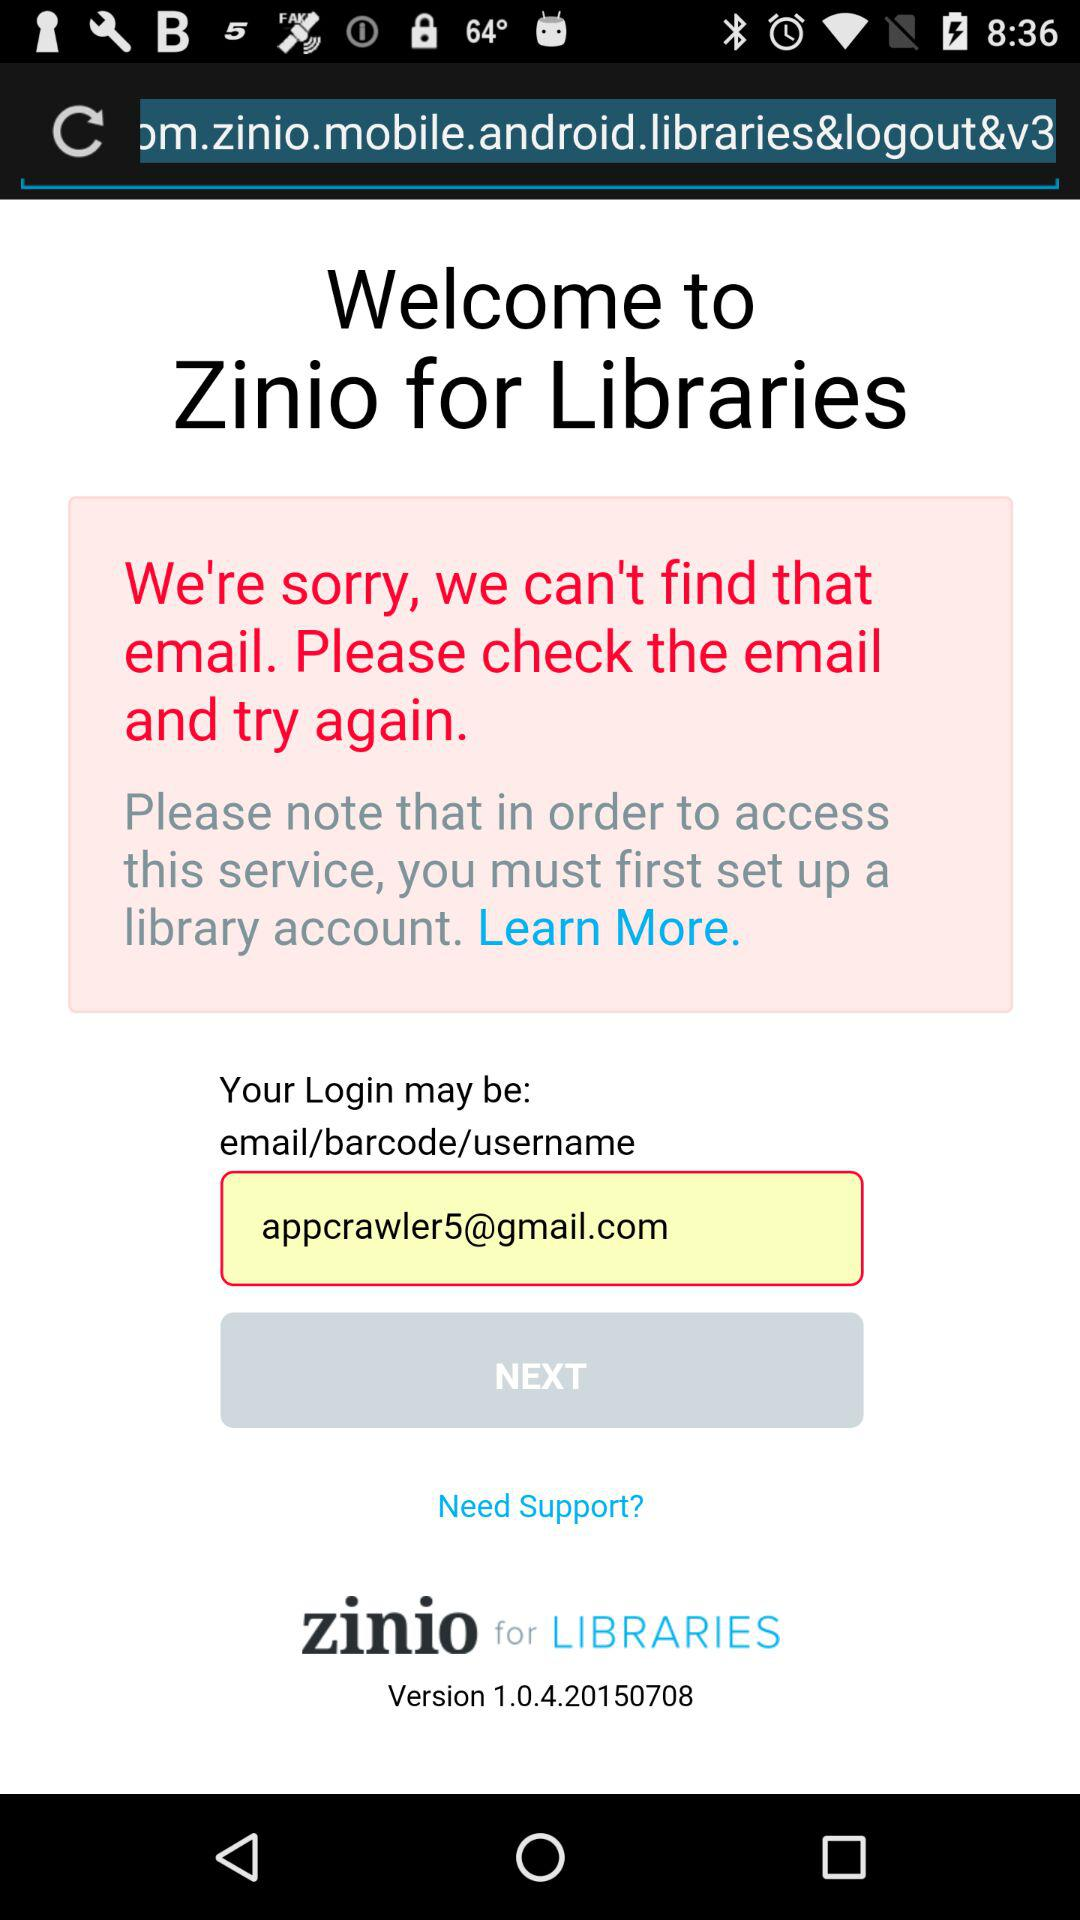What is the name of the application? The name of the application is "Zinio for Libraries". 